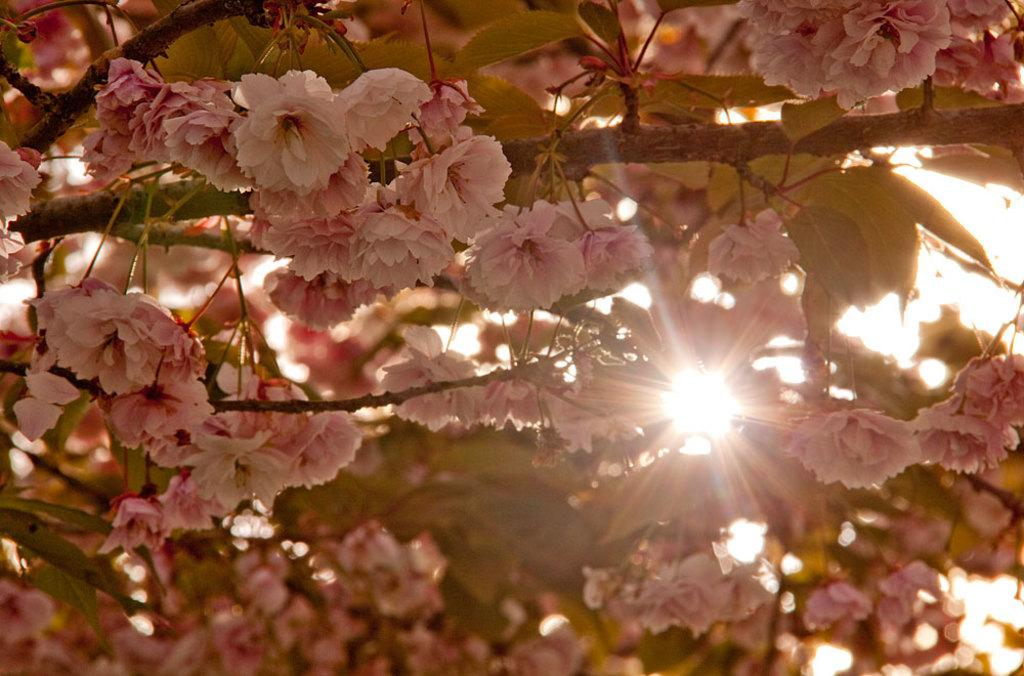What type of plant can be seen in the image? There is a tree with flowers in the image. What is the source of light in the image? The sun is visible in the image. What type of hair can be seen on the squirrel in the image? There is no squirrel present in the image, so there is no hair to observe. What type of dog can be seen playing with the flowers in the image? There is no dog present in the image, and the flowers are on a tree, not being played with. 